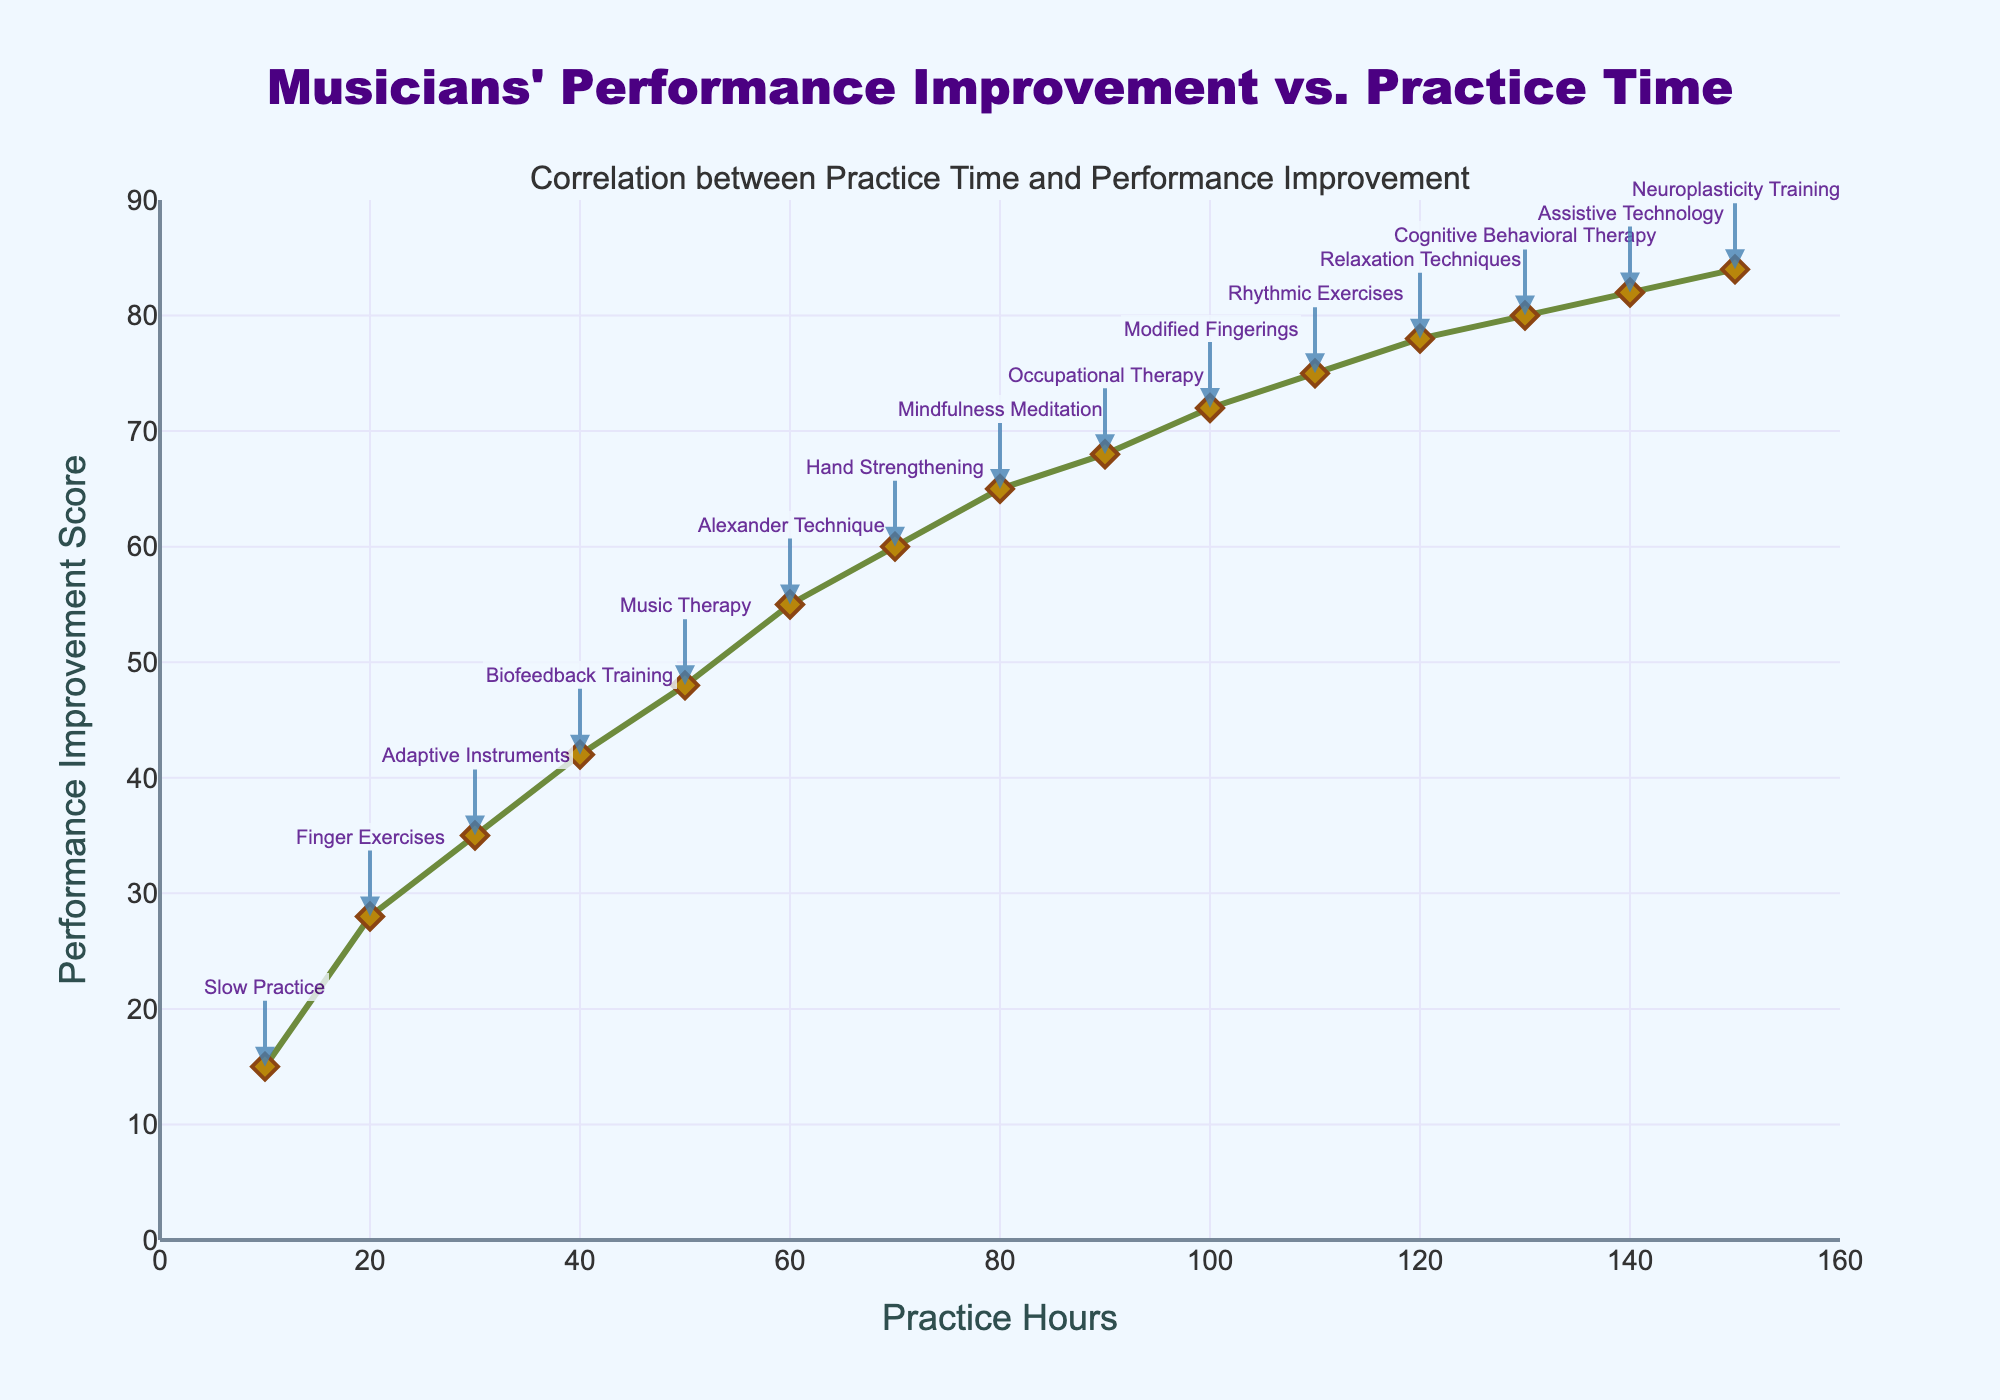What is the performance improvement score at 50 practice hours? Look at the performance improvement score on the y-axis corresponding to 50 practice hours on the x-axis.
Answer: 48 Which practice technique corresponds to 90 practice hours? Identify the annotation at 90 practice hours on the x-axis and note the technique mentioned.
Answer: Occupational Therapy At how many practice hours does the performance improvement score reach 75? Locate the y-axis value of 75 on the chart and see which x-axis value corresponds to it.
Answer: 110 How does the performance improvement score change from 20 practice hours to 100 practice hours? Find the y-axis values for 20 practice hours (28) and 100 practice hours (72), then calculate the difference.
Answer: +44 Which practice technique leads to the highest performance improvement score, and what is that score? Look for the highest point on the y-axis and note both the value and the corresponding practice technique annotation.
Answer: Neuroplasticity Training, 84 What is the difference in performance improvement score between 60 and 120 practice hours? Locate the performance improvement scores at 60 and 120 practice hours (55 and 78 respectively), then calculate the difference.
Answer: 23 How many techniques have a performance improvement score greater than 70? Count the techniques annotated above the y-axis value of 70.
Answer: 3 Which practice technique corresponds to the lowest performance improvement score in the plot? Identify the lowest point on the y-axis and note the corresponding practice technique.
Answer: Slow Practice What is the average performance improvement score across 40, 80, and 140 practice hours? Note the performance improvement scores for 40 (42), 80 (65), and 140 (82) practice hours, sum them up, and divide by 3: (42 + 65 + 82) / 3 = 63
Answer: 63 Does the performance improvement score increase steadily with increased practice hours? Examine the trend line from left to right and observe if there are any significant decreases.
Answer: Yes 